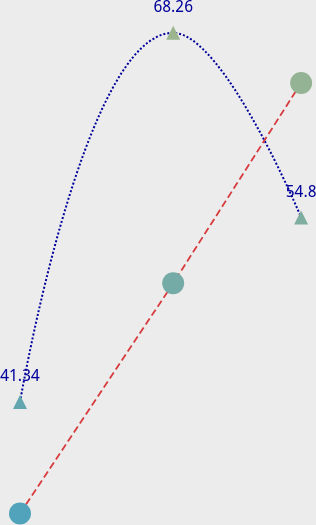Convert chart to OTSL. <chart><loc_0><loc_0><loc_500><loc_500><line_chart><ecel><fcel>2007<fcel>2008<nl><fcel>44.85<fcel>41.34<fcel>33.22<nl><fcel>64.11<fcel>68.26<fcel>50<nl><fcel>80.2<fcel>54.8<fcel>64.61<nl><fcel>205.79<fcel>175.91<fcel>114.99<nl></chart> 